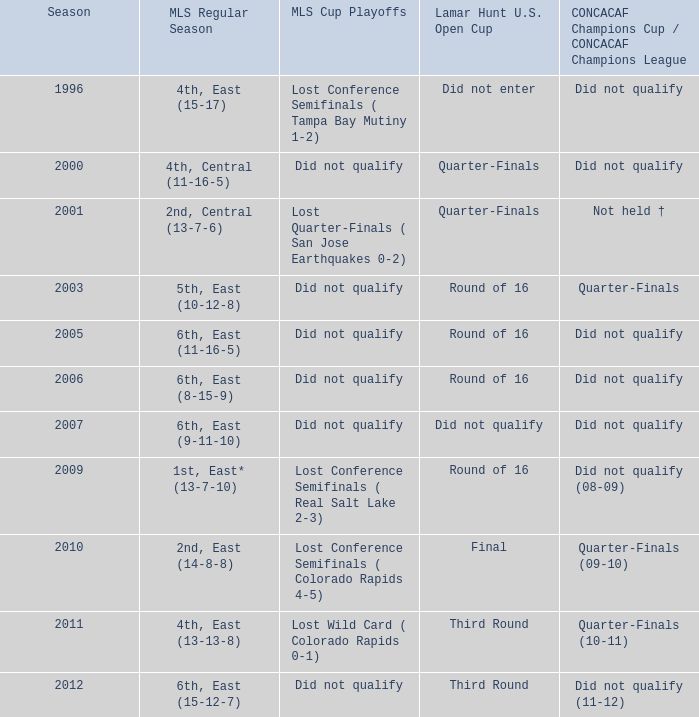What was the mls cup playoffs when concacaf champions cup / concacaf champions league was quarter-finals (09-10)? Lost Conference Semifinals ( Colorado Rapids 4-5). 